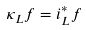Convert formula to latex. <formula><loc_0><loc_0><loc_500><loc_500>\kappa _ { L } f = i ^ { * } _ { L } f</formula> 